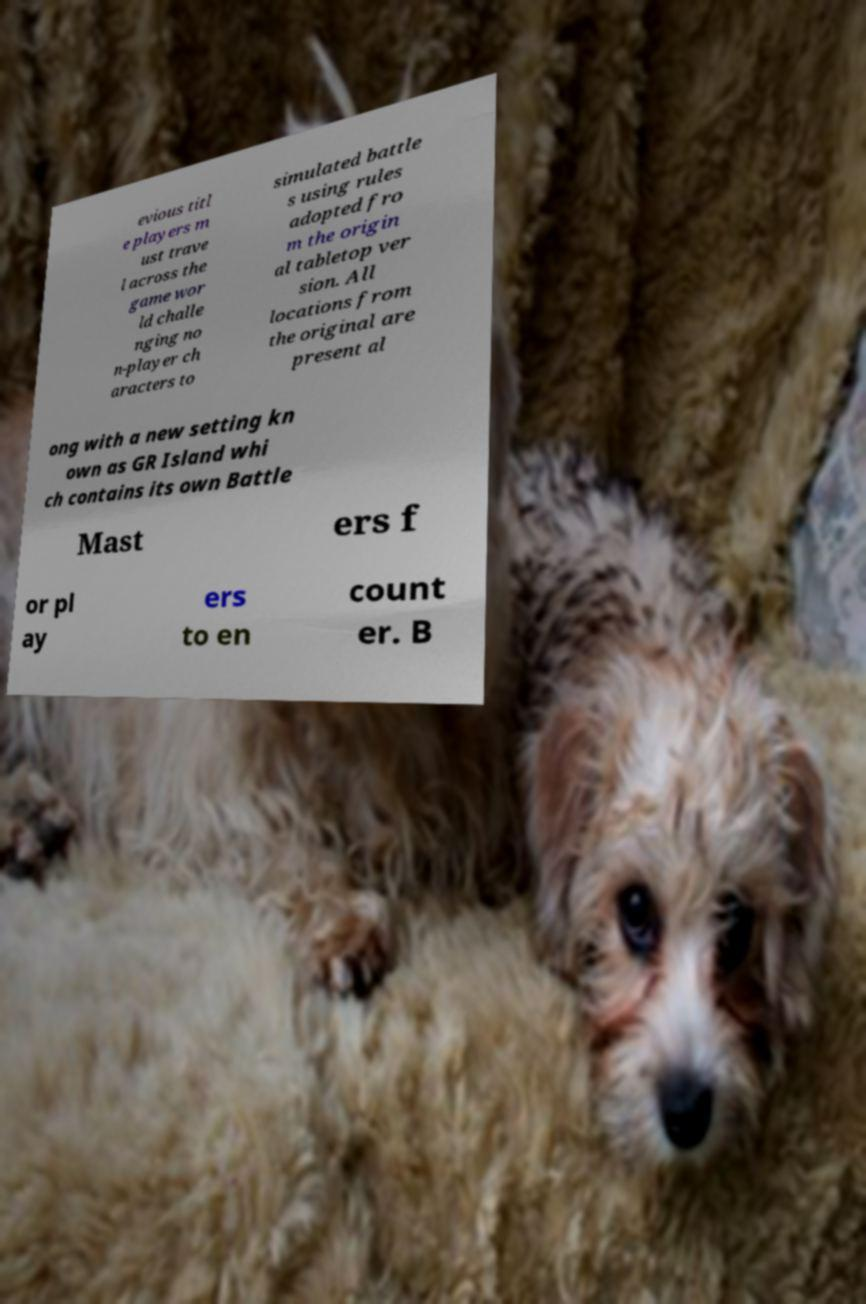There's text embedded in this image that I need extracted. Can you transcribe it verbatim? evious titl e players m ust trave l across the game wor ld challe nging no n-player ch aracters to simulated battle s using rules adopted fro m the origin al tabletop ver sion. All locations from the original are present al ong with a new setting kn own as GR Island whi ch contains its own Battle Mast ers f or pl ay ers to en count er. B 